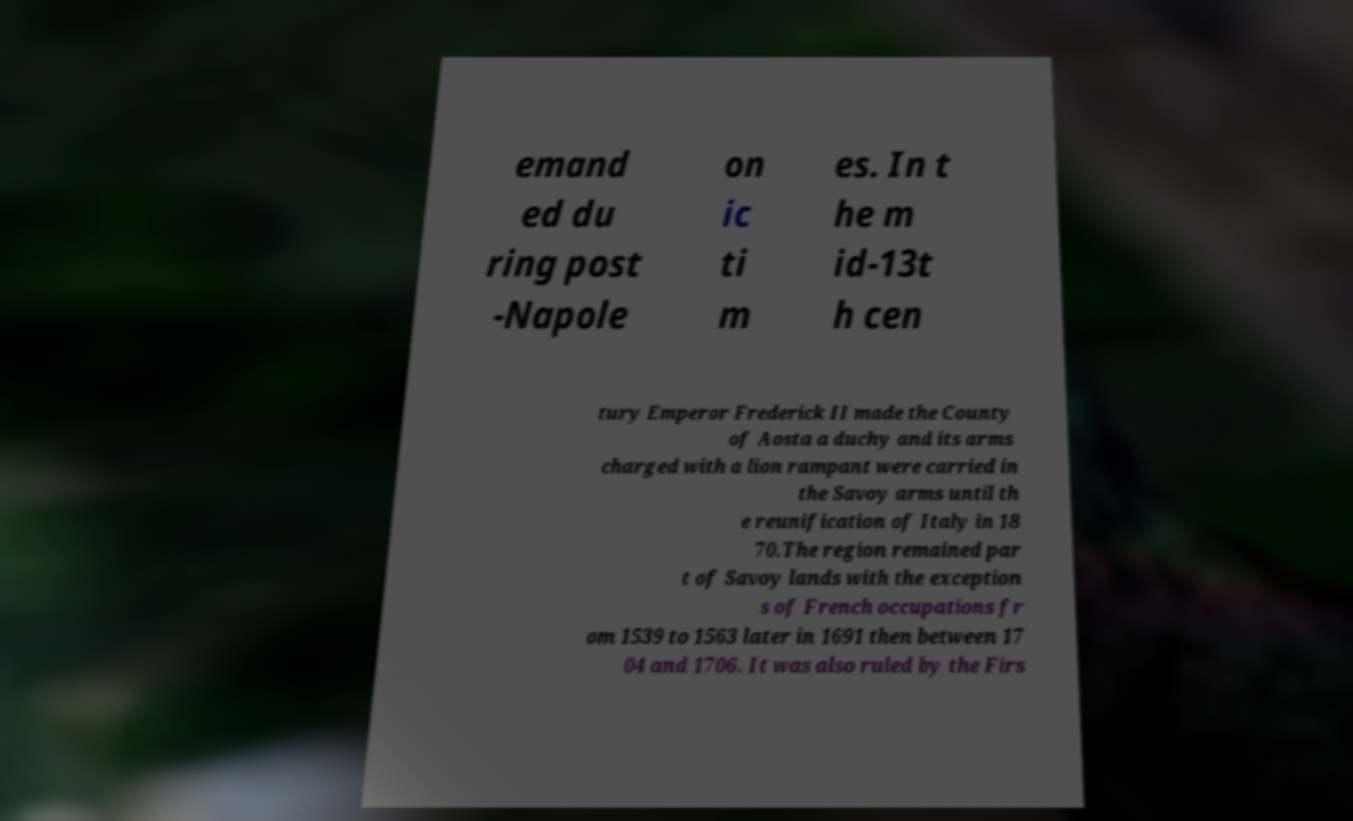Please read and relay the text visible in this image. What does it say? emand ed du ring post -Napole on ic ti m es. In t he m id-13t h cen tury Emperor Frederick II made the County of Aosta a duchy and its arms charged with a lion rampant were carried in the Savoy arms until th e reunification of Italy in 18 70.The region remained par t of Savoy lands with the exception s of French occupations fr om 1539 to 1563 later in 1691 then between 17 04 and 1706. It was also ruled by the Firs 